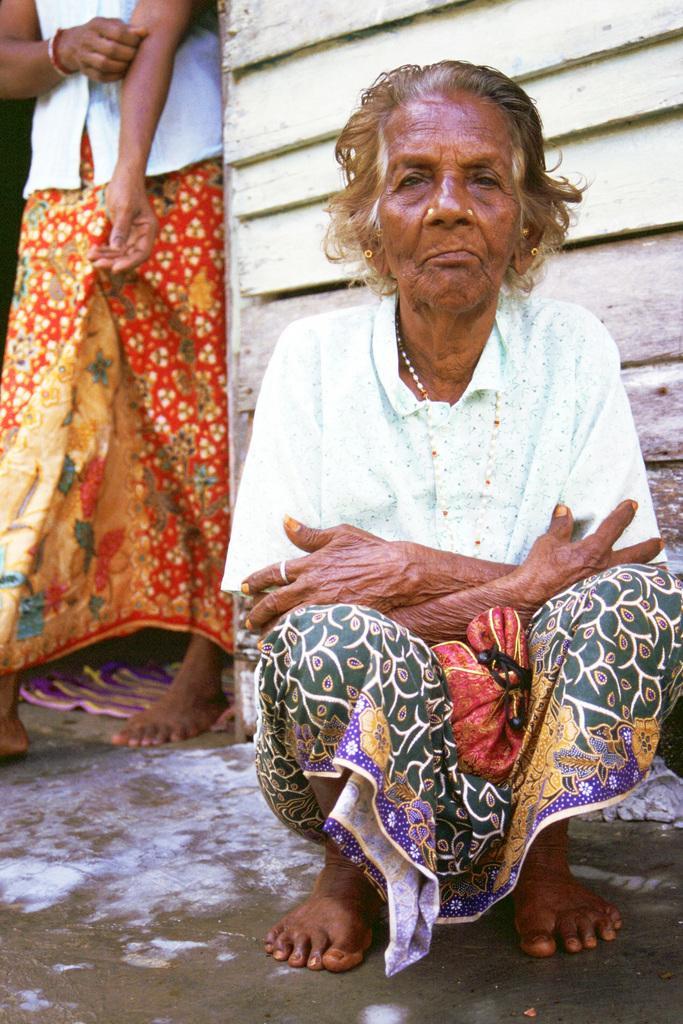Could you give a brief overview of what you see in this image? In this image we can see two women. Of them one is sitting on the floor and the other is standing on the floor. 